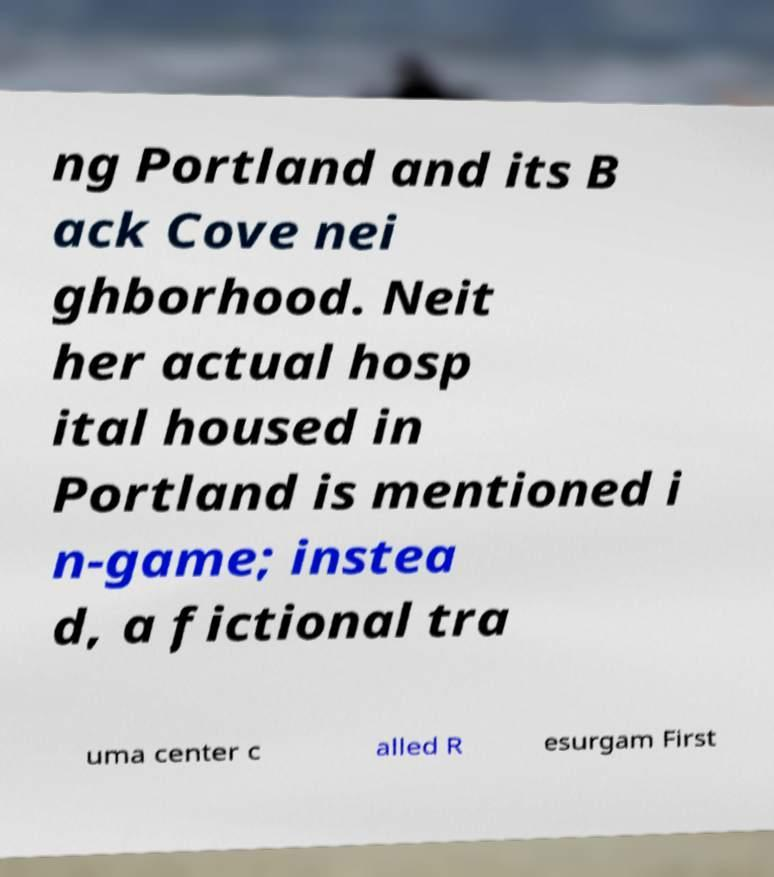Please read and relay the text visible in this image. What does it say? ng Portland and its B ack Cove nei ghborhood. Neit her actual hosp ital housed in Portland is mentioned i n-game; instea d, a fictional tra uma center c alled R esurgam First 